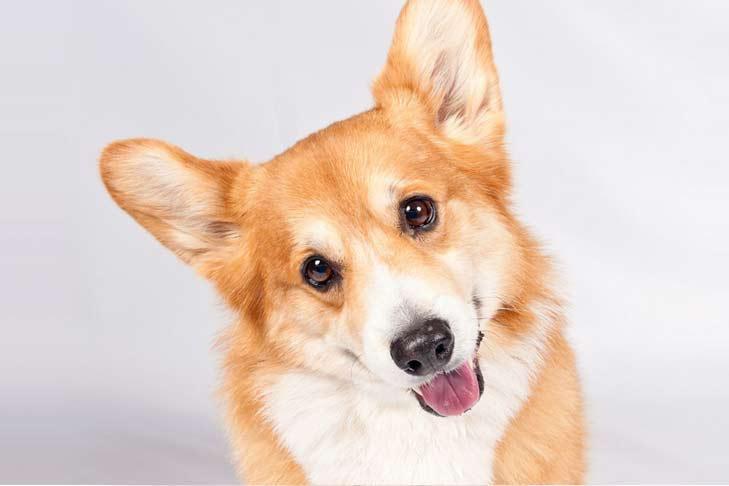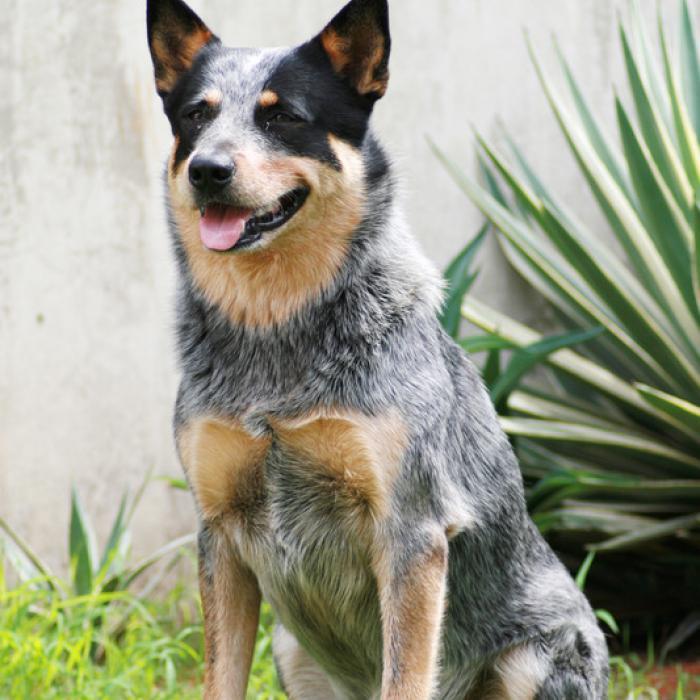The first image is the image on the left, the second image is the image on the right. For the images displayed, is the sentence "Each image contains one short-legged corgi, and all dogs are posed on green grass." factually correct? Answer yes or no. No. The first image is the image on the left, the second image is the image on the right. Analyze the images presented: Is the assertion "A single dog is standing in the grass in the image on the right." valid? Answer yes or no. No. 